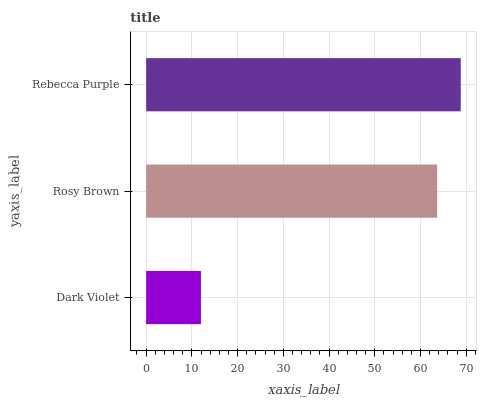Is Dark Violet the minimum?
Answer yes or no. Yes. Is Rebecca Purple the maximum?
Answer yes or no. Yes. Is Rosy Brown the minimum?
Answer yes or no. No. Is Rosy Brown the maximum?
Answer yes or no. No. Is Rosy Brown greater than Dark Violet?
Answer yes or no. Yes. Is Dark Violet less than Rosy Brown?
Answer yes or no. Yes. Is Dark Violet greater than Rosy Brown?
Answer yes or no. No. Is Rosy Brown less than Dark Violet?
Answer yes or no. No. Is Rosy Brown the high median?
Answer yes or no. Yes. Is Rosy Brown the low median?
Answer yes or no. Yes. Is Dark Violet the high median?
Answer yes or no. No. Is Rebecca Purple the low median?
Answer yes or no. No. 